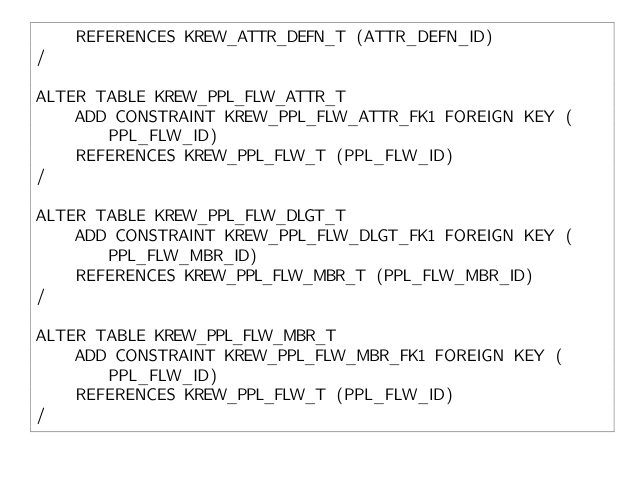Convert code to text. <code><loc_0><loc_0><loc_500><loc_500><_SQL_>    REFERENCES KREW_ATTR_DEFN_T (ATTR_DEFN_ID)
/

ALTER TABLE KREW_PPL_FLW_ATTR_T
    ADD CONSTRAINT KREW_PPL_FLW_ATTR_FK1 FOREIGN KEY (PPL_FLW_ID)
    REFERENCES KREW_PPL_FLW_T (PPL_FLW_ID)
/

ALTER TABLE KREW_PPL_FLW_DLGT_T
    ADD CONSTRAINT KREW_PPL_FLW_DLGT_FK1 FOREIGN KEY (PPL_FLW_MBR_ID)
    REFERENCES KREW_PPL_FLW_MBR_T (PPL_FLW_MBR_ID)
/

ALTER TABLE KREW_PPL_FLW_MBR_T
    ADD CONSTRAINT KREW_PPL_FLW_MBR_FK1 FOREIGN KEY (PPL_FLW_ID)
    REFERENCES KREW_PPL_FLW_T (PPL_FLW_ID)
/
</code> 